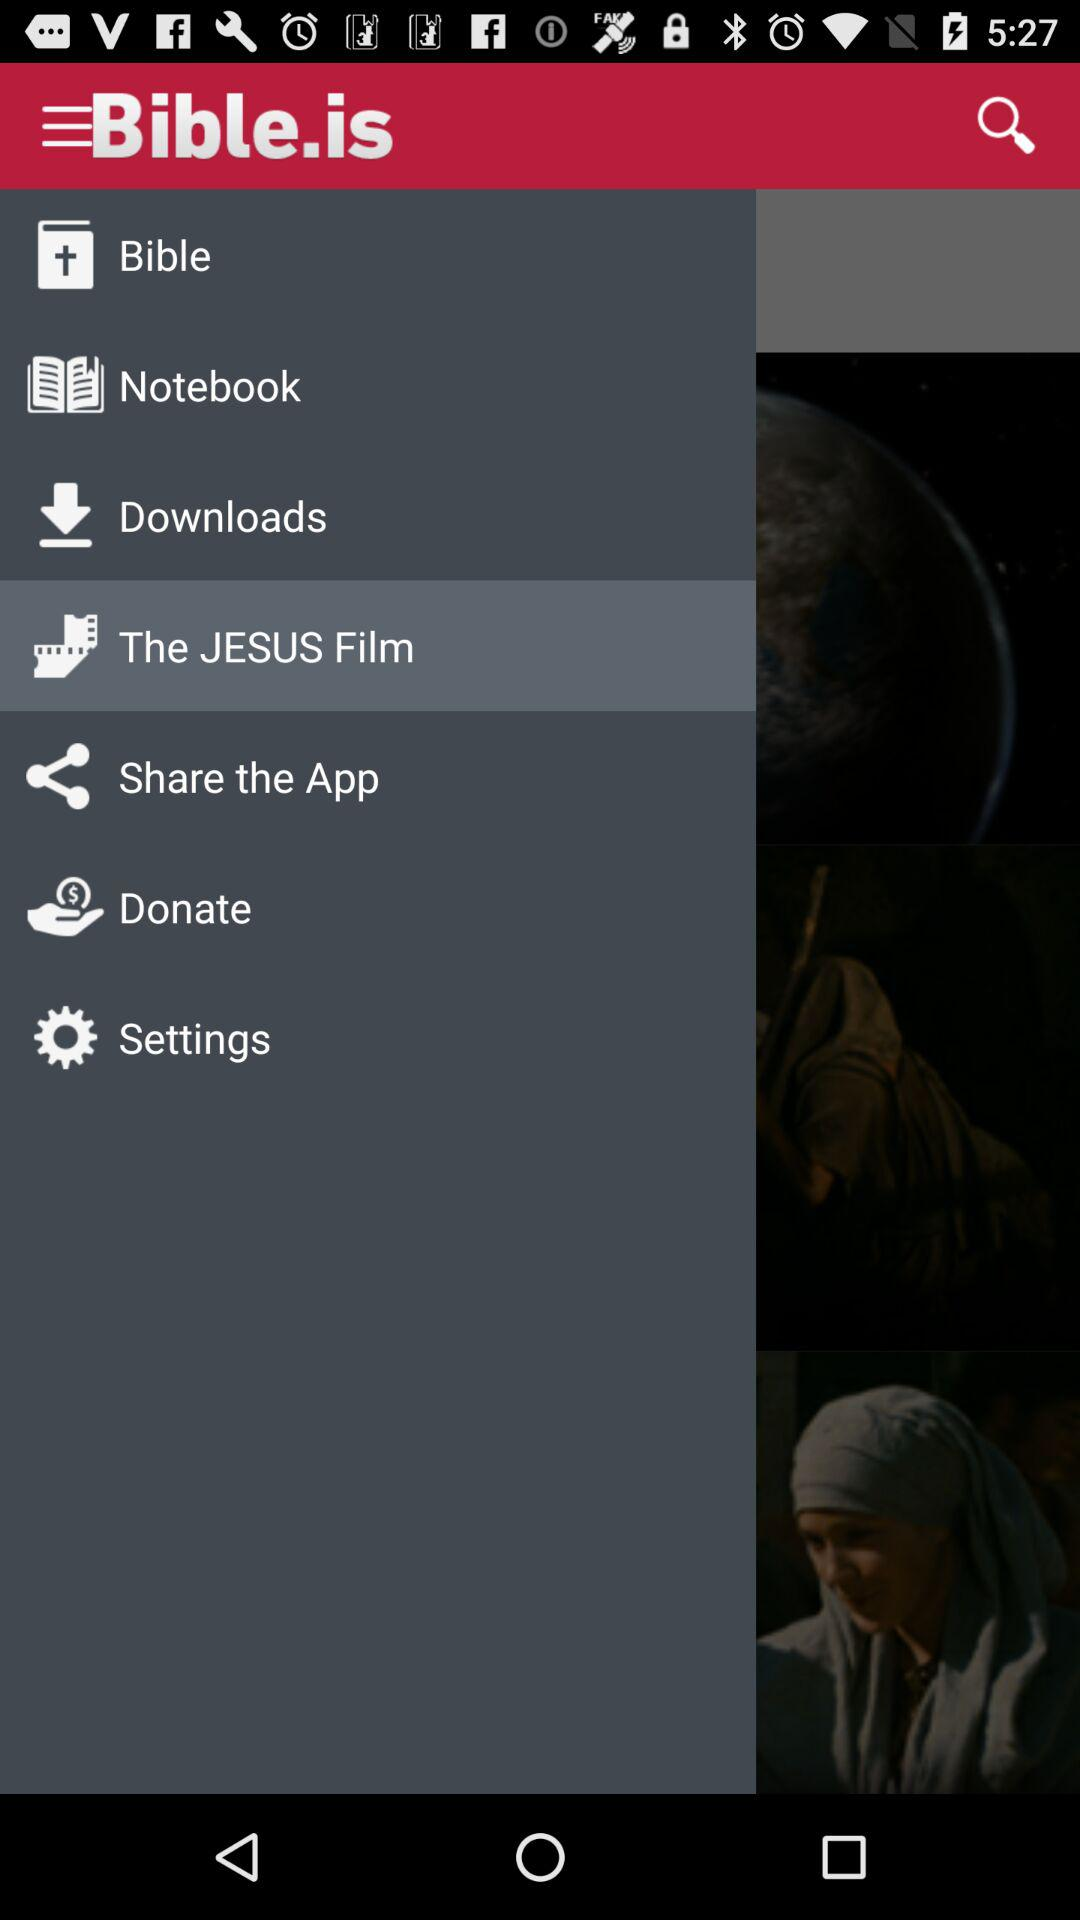Which item is selected in the menu? The selected item in the menu is "The JESUS Film". 